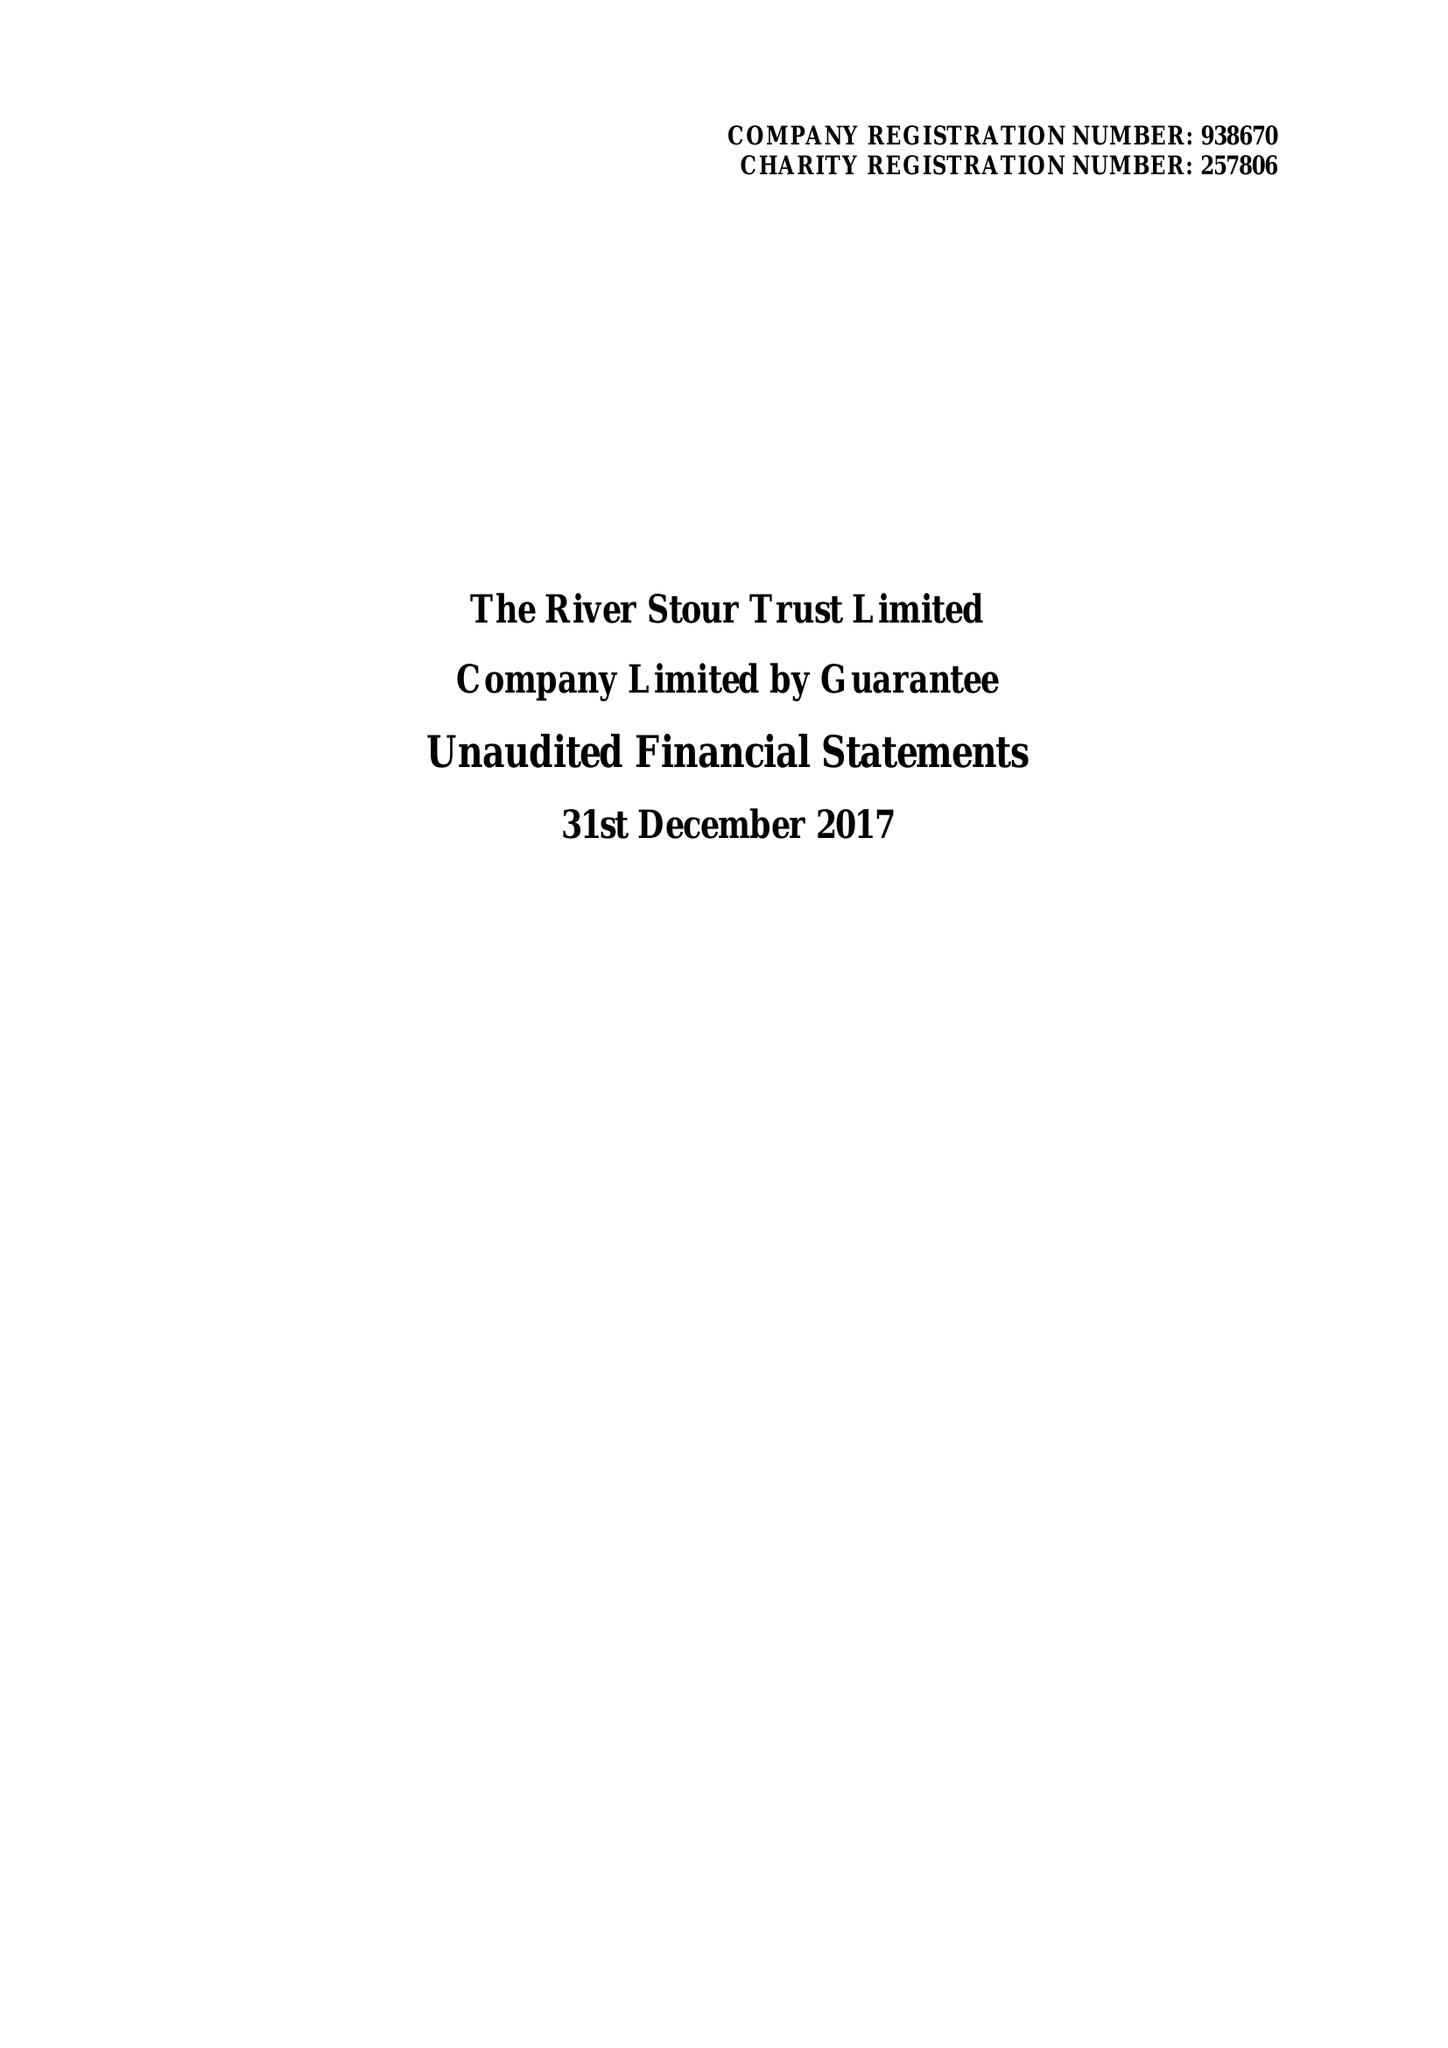What is the value for the report_date?
Answer the question using a single word or phrase. 2017-12-31 